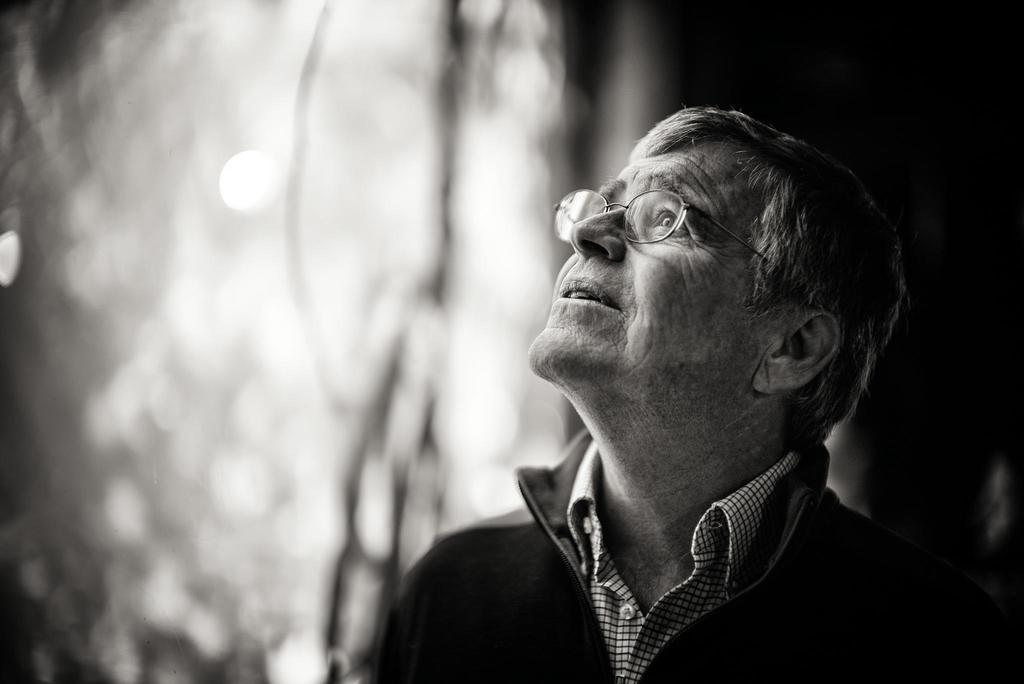What is present in the image? There is a man in the image. What is the man doing in the image? The man is looking upwards. What can be seen on the man's face? The man is wearing spectacles. Can you describe the background of the image? The background of the image is blurred. What type of silver object is the man holding in the image? There is no silver object present in the image. What historical event is the man referring to in the image? There is no indication of any historical event or reference in the image. What brand of toothpaste is the man using in the image? There is no toothpaste or any indication of personal care products in the image. 